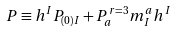Convert formula to latex. <formula><loc_0><loc_0><loc_500><loc_500>P \equiv h ^ { I } P _ { ( 0 ) I } + P ^ { r = 3 } _ { a } m _ { I } ^ { a } h ^ { I }</formula> 